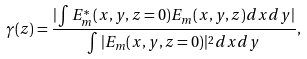Convert formula to latex. <formula><loc_0><loc_0><loc_500><loc_500>\gamma ( z ) = \frac { | \int E ^ { * } _ { m } ( x , y , z = 0 ) E _ { m } ( x , y , z ) d x d y | } { \int | E _ { m } ( x , y , z = 0 ) | ^ { 2 } d x d y } ,</formula> 